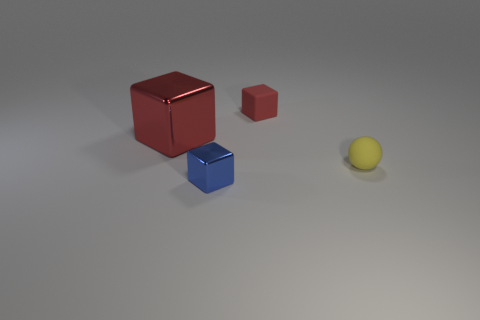Subtract all metal blocks. How many blocks are left? 1 Subtract all spheres. How many objects are left? 3 Subtract all blue blocks. How many blocks are left? 2 Add 1 red metal blocks. How many objects exist? 5 Subtract all blue balls. How many red blocks are left? 2 Add 3 tiny yellow matte balls. How many tiny yellow matte balls are left? 4 Add 4 small gray cubes. How many small gray cubes exist? 4 Subtract 2 red cubes. How many objects are left? 2 Subtract 1 balls. How many balls are left? 0 Subtract all cyan cubes. Subtract all purple balls. How many cubes are left? 3 